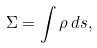Convert formula to latex. <formula><loc_0><loc_0><loc_500><loc_500>\Sigma = \int \rho \, d s ,</formula> 